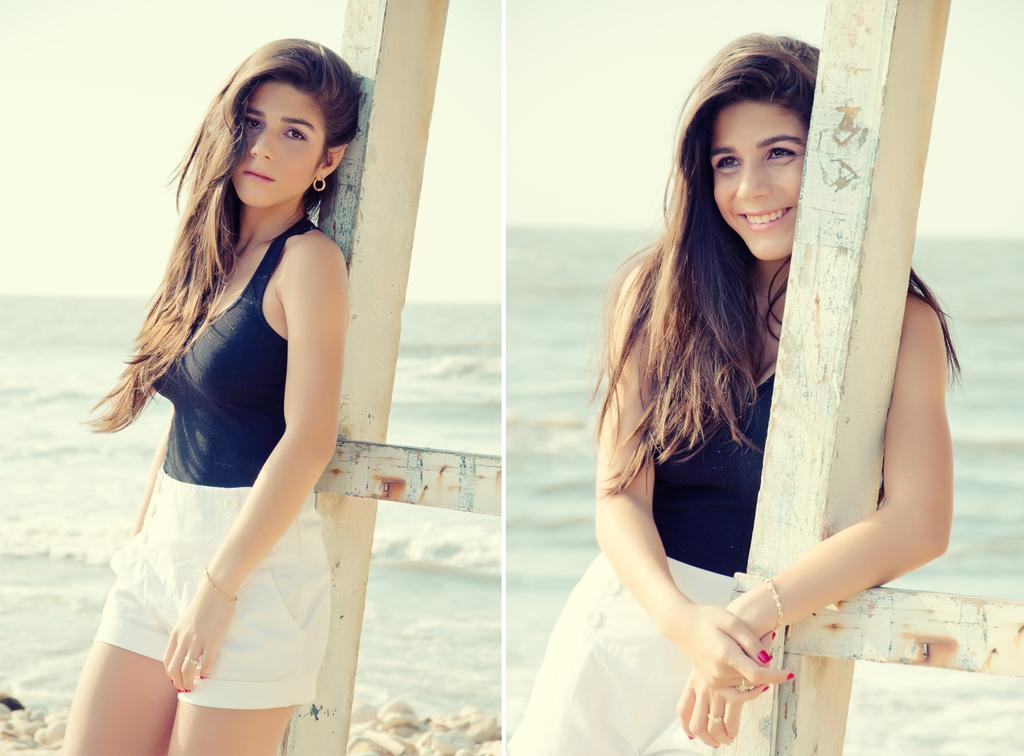What is the main subject of the image? There is a beautiful girl in the image. What is the girl doing in the image? The girl is standing in the image. What colors is the girl wearing? She is wearing a black color top and a white color short. What expression does the girl have on her face? The girl is smiling on the right side. What can be seen in the background of the image? There is water visible in the image. What type of hammer is the girl holding in the image? There is no hammer present in the image; the girl is not holding any tool. 